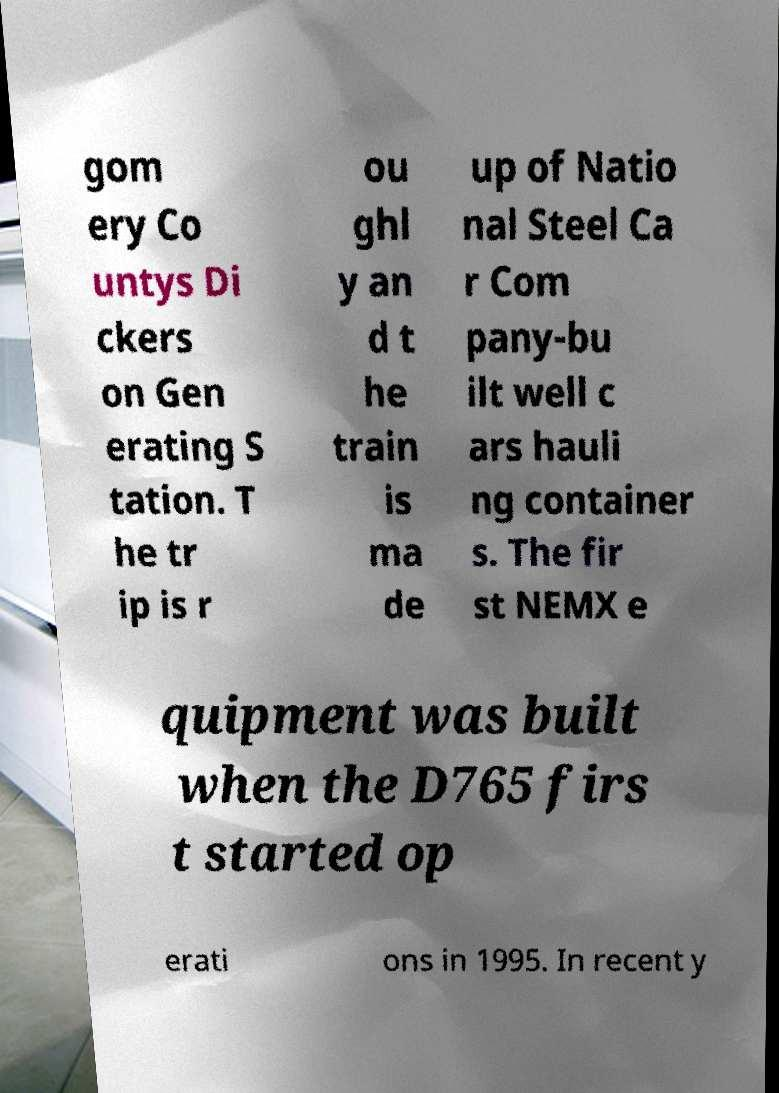Could you extract and type out the text from this image? gom ery Co untys Di ckers on Gen erating S tation. T he tr ip is r ou ghl y an d t he train is ma de up of Natio nal Steel Ca r Com pany-bu ilt well c ars hauli ng container s. The fir st NEMX e quipment was built when the D765 firs t started op erati ons in 1995. In recent y 